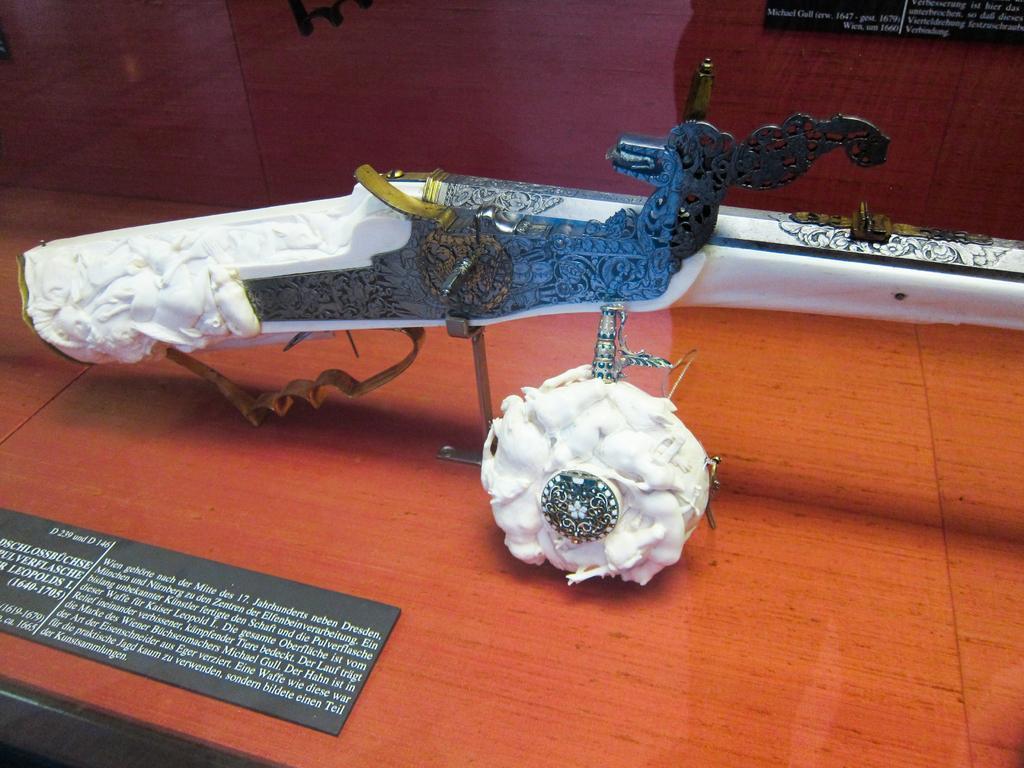Describe this image in one or two sentences. In this image, we can see a mirror and in the background there are two white color objects, there is a black color board on that there is some text printed. 